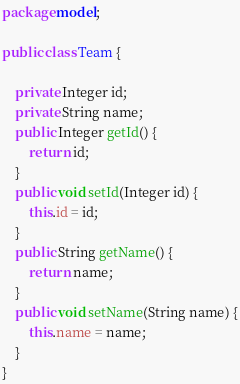<code> <loc_0><loc_0><loc_500><loc_500><_Java_>package model;

public class Team {

	private Integer id;
	private String name;
	public Integer getId() {
		return id;
	}
	public void setId(Integer id) {
		this.id = id;
	}
	public String getName() {
		return name;
	}
	public void setName(String name) {
		this.name = name;
	}
}
</code> 